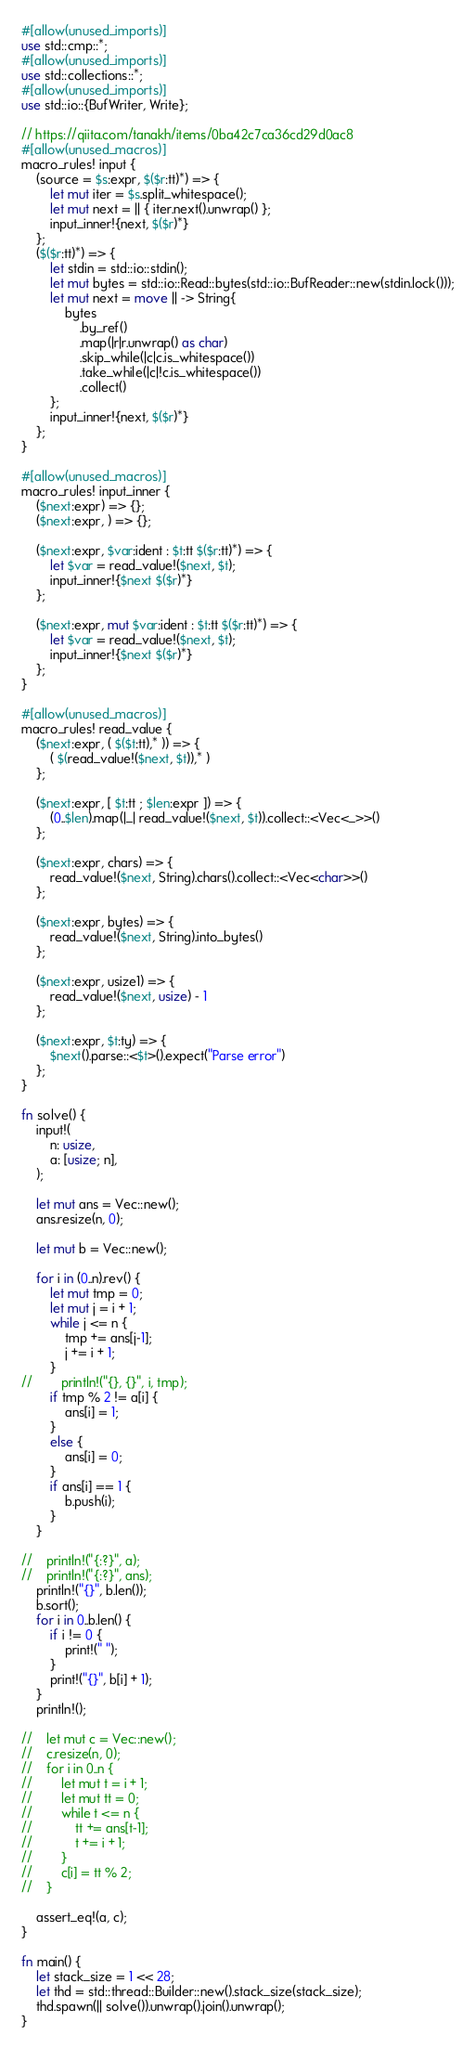Convert code to text. <code><loc_0><loc_0><loc_500><loc_500><_Rust_>#[allow(unused_imports)]
use std::cmp::*;
#[allow(unused_imports)]
use std::collections::*;
#[allow(unused_imports)]
use std::io::{BufWriter, Write};

// https://qiita.com/tanakh/items/0ba42c7ca36cd29d0ac8
#[allow(unused_macros)]
macro_rules! input {
    (source = $s:expr, $($r:tt)*) => {
        let mut iter = $s.split_whitespace();
        let mut next = || { iter.next().unwrap() };
        input_inner!{next, $($r)*}
    };
    ($($r:tt)*) => {
        let stdin = std::io::stdin();
        let mut bytes = std::io::Read::bytes(std::io::BufReader::new(stdin.lock()));
        let mut next = move || -> String{
            bytes
                .by_ref()
                .map(|r|r.unwrap() as char)
                .skip_while(|c|c.is_whitespace())
                .take_while(|c|!c.is_whitespace())
                .collect()
        };
        input_inner!{next, $($r)*}
    };
}

#[allow(unused_macros)]
macro_rules! input_inner {
    ($next:expr) => {};
    ($next:expr, ) => {};

    ($next:expr, $var:ident : $t:tt $($r:tt)*) => {
        let $var = read_value!($next, $t);
        input_inner!{$next $($r)*}
    };

    ($next:expr, mut $var:ident : $t:tt $($r:tt)*) => {
        let $var = read_value!($next, $t);
        input_inner!{$next $($r)*}
    };
}

#[allow(unused_macros)]
macro_rules! read_value {
    ($next:expr, ( $($t:tt),* )) => {
        ( $(read_value!($next, $t)),* )
    };

    ($next:expr, [ $t:tt ; $len:expr ]) => {
        (0..$len).map(|_| read_value!($next, $t)).collect::<Vec<_>>()
    };

    ($next:expr, chars) => {
        read_value!($next, String).chars().collect::<Vec<char>>()
    };

    ($next:expr, bytes) => {
        read_value!($next, String).into_bytes()
    };

    ($next:expr, usize1) => {
        read_value!($next, usize) - 1
    };

    ($next:expr, $t:ty) => {
        $next().parse::<$t>().expect("Parse error")
    };
}

fn solve() {
    input!(
        n: usize,
        a: [usize; n],
    );

    let mut ans = Vec::new();
    ans.resize(n, 0);

    let mut b = Vec::new();

    for i in (0..n).rev() {
        let mut tmp = 0;
        let mut j = i + 1;
        while j <= n {
            tmp += ans[j-1];
            j += i + 1;
        }
//        println!("{}, {}", i, tmp);
        if tmp % 2 != a[i] {
            ans[i] = 1;
        }
        else {
            ans[i] = 0;
        }
        if ans[i] == 1 {
            b.push(i);
        }
    }

//    println!("{:?}", a);
//    println!("{:?}", ans);
    println!("{}", b.len());
    b.sort();
    for i in 0..b.len() {
        if i != 0 {
            print!(" ");
        }
        print!("{}", b[i] + 1);
    }
    println!();

//    let mut c = Vec::new();
//    c.resize(n, 0);
//    for i in 0..n {
//        let mut t = i + 1;
//        let mut tt = 0;
//        while t <= n {
//            tt += ans[t-1];
//            t += i + 1;
//        }
//        c[i] = tt % 2;
//    }

    assert_eq!(a, c);
}

fn main() {
    let stack_size = 1 << 28;
    let thd = std::thread::Builder::new().stack_size(stack_size);
    thd.spawn(|| solve()).unwrap().join().unwrap();
}
</code> 